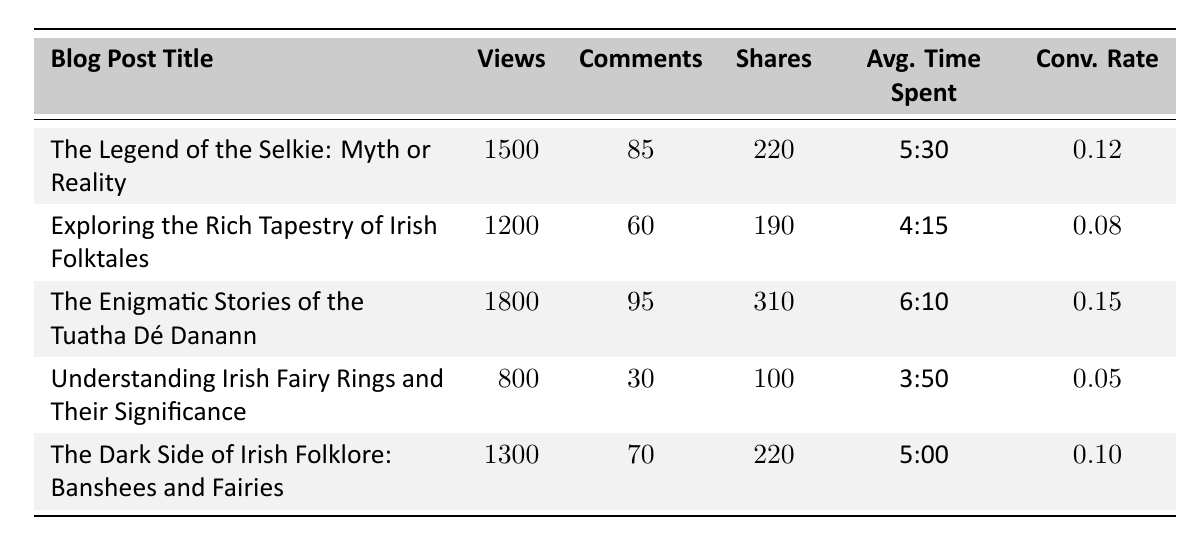What is the title of the blog post with the highest views? The blog post with the highest views is "The Enigmatic Stories of the Tuatha Dé Danann," which has 1800 views.
Answer: The Enigmatic Stories of the Tuatha Dé Danann How many comments did the blog post titled "Exploring the Rich Tapestry of Irish Folktales" receive? The blog post "Exploring the Rich Tapestry of Irish Folktales" received 60 comments, as indicated in the comments column for that specific row in the table.
Answer: 60 What is the average conversion rate of all the blog posts listed? The conversion rates are 0.12, 0.08, 0.15, 0.05, and 0.10. Adding them gives 0.12 + 0.08 + 0.15 + 0.05 + 0.10 = 0.50. There are 5 posts, so the average conversion rate is 0.50 / 5 = 0.10.
Answer: 0.10 Is the average time spent on "Understanding Irish Fairy Rings and Their Significance" greater than 5 minutes? The average time spent on "Understanding Irish Fairy Rings and Their Significance" is 3:50, which is less than 5 minutes. Thus, the statement is false.
Answer: No Which blog post has the highest number of shares? "The Enigmatic Stories of the Tuatha Dé Danann" has the highest number of shares with 310, as it is the largest value in the shares column.
Answer: The Enigmatic Stories of the Tuatha Dé Danann How many total views did the blogs about "The Dark Side of Irish Folklore" and "Understanding Irish Fairy Rings" receive combined? The views for "The Dark Side of Irish Folklore: Banshees and Fairies" are 1300, and for "Understanding Irish Fairy Rings and Their Significance," they are 800. Adding these gives 1300 + 800 = 2100 total views.
Answer: 2100 Does the blog post "The Legend of the Selkie: Myth or Reality" have a higher conversion rate than "The Dark Side of Irish Folklore"? The conversion rate for "The Legend of the Selkie: Myth or Reality" is 0.12, while for "The Dark Side of Irish Folklore," it is 0.10. Since 0.12 is greater than 0.10, the statement is true.
Answer: Yes What is the difference in comments between "The Enigmatic Stories of the Tuatha Dé Danann" and "Understanding Irish Fairy Rings"? "The Enigmatic Stories of the Tuatha Dé Danann" has 95 comments, and "Understanding Irish Fairy Rings" has 30. The difference is 95 - 30 = 65 comments.
Answer: 65 